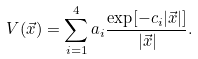Convert formula to latex. <formula><loc_0><loc_0><loc_500><loc_500>V ( \vec { x } ) = \sum _ { i = 1 } ^ { 4 } a _ { i } \frac { \exp [ - c _ { i } | \vec { x } | ] } { | \vec { x } | } .</formula> 